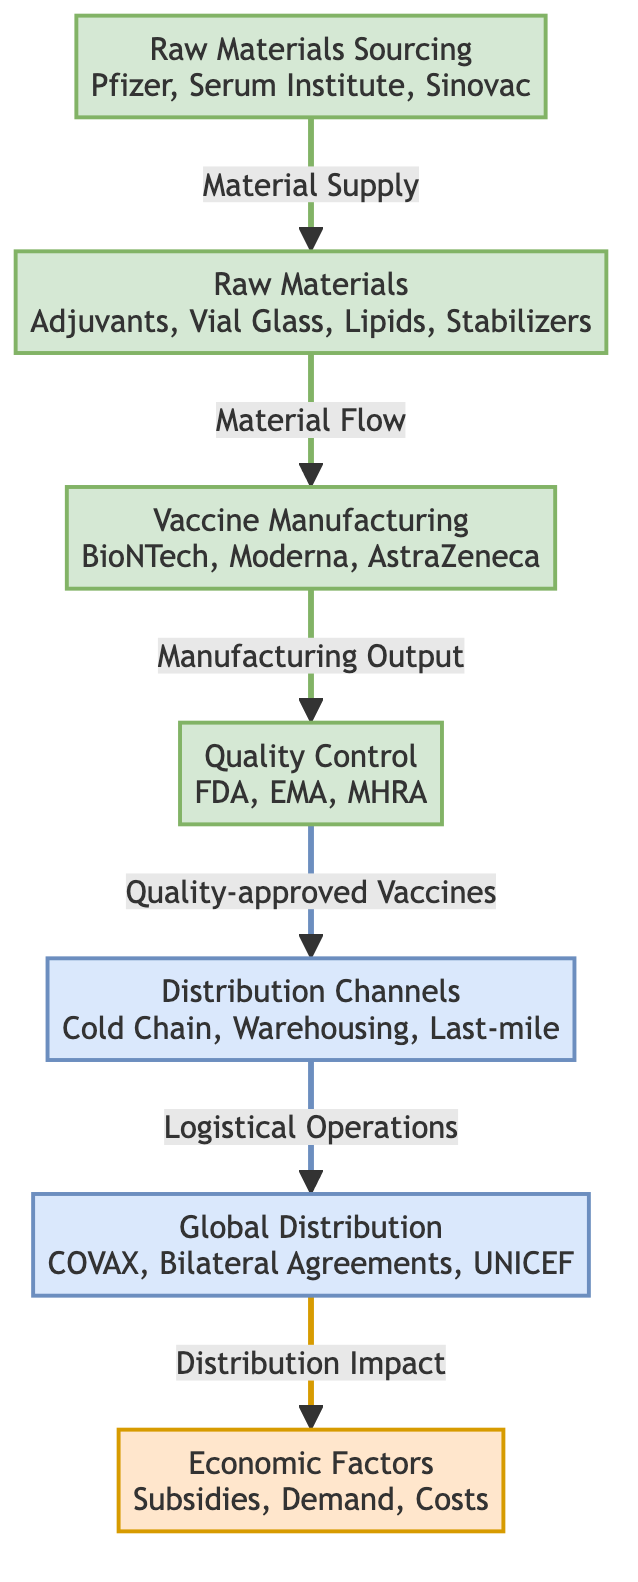What are the primary sources of raw materials in vaccine production? The diagram lists Pfizer, Serum Institute, and Sinovac as the key companies involved in sourcing raw materials, showcasing these entities' roles as suppliers.
Answer: Pfizer, Serum Institute, Sinovac How many nodes represent the manufacturing aspects in the diagram? There are three nodes that specifically deal with manufacturing: “Raw Materials,” “Vaccine Manufacturing,” and “Quality Control,” leading to a count of three manufacturing-related nodes.
Answer: 3 What is the last step before vaccines are distributed globally? The last step before global distribution is linked to the distribution channels, which involve logistical operations necessary for moving the vaccines to different locations and organizations.
Answer: Logistical Operations Which economic factors are considered in the global vaccination supply chain? The diagram highlights several economic factors including subsidies, demand, and costs that influence the overall availability and pricing of vaccines.
Answer: Subsidies, Demand, Costs What is the role of COVAX in the distribution process? COVAX is identified in the distribution process as a major initiative responsible for ensuring equitable access to vaccines globally, representing its significant influence in this context.
Answer: COVAX How does quality control impact vaccine availability? The quality control process involves organizations like FDA, EMA, and MHRA, which ensure that only quality-approved vaccines proceed to distribution, thus affecting availability by highlighting the rigorous approval process.
Answer: Quality-approved Vaccines What type of transport is mentioned in the distribution channels? The diagram specifically mentions "Cold Chain" as a type of transport, indicating the temperature-controlled logistics necessary for distributing vaccines effectively.
Answer: Cold Chain What is the flow of materials from raw materials to distribution? The flow starts with sourcing raw materials, which transits to manufacturing, followed by quality control, then moves to distribution channels leading to global distribution, and finally influences economic factors, illustrating a comprehensive supply chain.
Answer: Sourcing to Global Distribution Which organizations are responsible for quality control? The organizations responsible for quality control as specified in the diagram are FDA, EMA, and MHRA, representing the regulatory oversight necessary to ensure vaccine safety and efficacy before reaching the market.
Answer: FDA, EMA, MHRA 